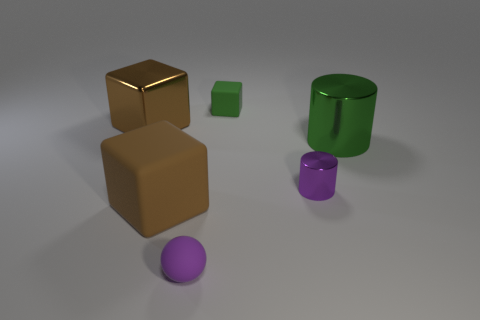Does the small metallic object have the same color as the matte sphere?
Make the answer very short. Yes. What is the material of the tiny cylinder?
Provide a succinct answer. Metal. What is the color of the matte cube in front of the purple cylinder?
Ensure brevity in your answer.  Brown. What number of small matte blocks have the same color as the big rubber object?
Your answer should be very brief. 0. What number of big objects are both to the left of the tiny purple cylinder and right of the large matte cube?
Offer a very short reply. 0. The other rubber object that is the same size as the purple rubber thing is what shape?
Offer a terse response. Cube. The brown matte thing has what size?
Your answer should be very brief. Large. What is the material of the brown object that is to the right of the thing to the left of the brown object that is on the right side of the big brown metallic object?
Your answer should be compact. Rubber. There is another large cylinder that is the same material as the purple cylinder; what is its color?
Give a very brief answer. Green. There is a tiny object that is right of the small green cube that is on the left side of the tiny purple metallic thing; how many brown matte things are in front of it?
Make the answer very short. 1. 